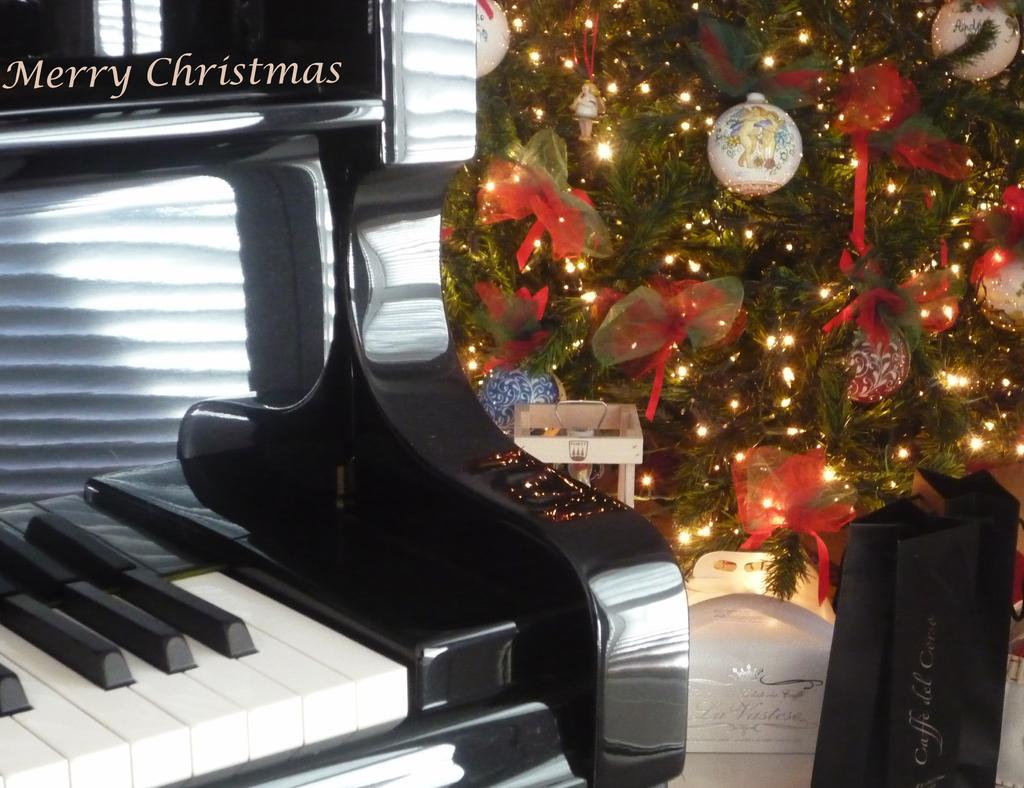What type of tree is in the image? There is a Christmas tree in the image. What other object can be seen on the ground in the image? There is a piano on the ground in the image. What is placed on the Christmas tree? The Christmas tree has objects on it. What type of plastic material is used to make the fireman's hat in the image? There is no fireman or hat present in the image; it features a Christmas tree and a piano. 